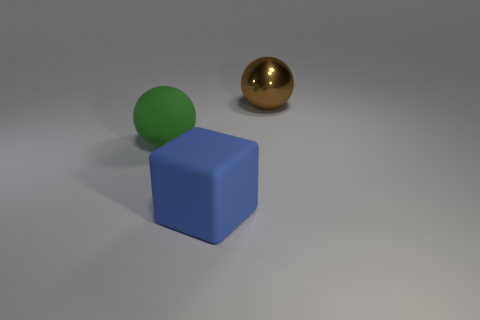What could be the purpose of this arrangement of objects? This arrangement of objects could serve several purposes. It might be an artistic composition aimed at exploring shapes and colors, a setup for a physics simulation testing how different materials interact with light, or a demonstration of 3D rendering techniques. In educational contexts, it could be used to teach about geometry, material properties, or the basics of shading in computer graphics. 